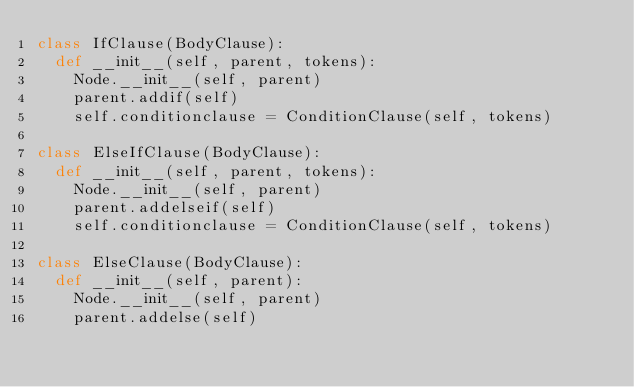Convert code to text. <code><loc_0><loc_0><loc_500><loc_500><_Python_>class IfClause(BodyClause):
	def __init__(self, parent, tokens):
		Node.__init__(self, parent)
		parent.addif(self)
		self.conditionclause = ConditionClause(self, tokens)

class ElseIfClause(BodyClause):
	def __init__(self, parent, tokens):
		Node.__init__(self, parent)
		parent.addelseif(self)
		self.conditionclause = ConditionClause(self, tokens)

class ElseClause(BodyClause):
	def __init__(self, parent):
		Node.__init__(self, parent)
		parent.addelse(self)
</code> 